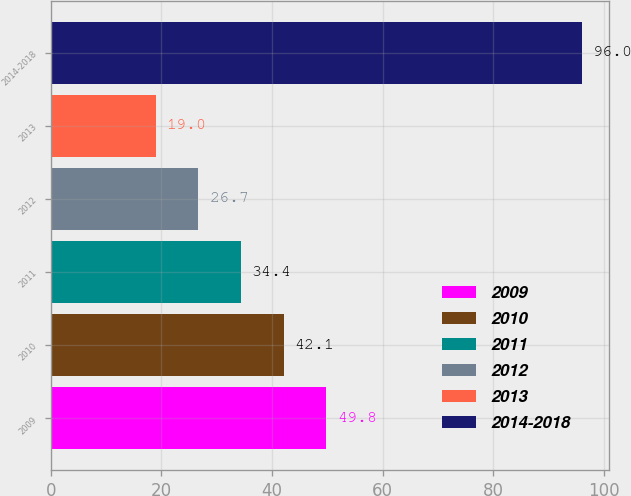<chart> <loc_0><loc_0><loc_500><loc_500><bar_chart><fcel>2009<fcel>2010<fcel>2011<fcel>2012<fcel>2013<fcel>2014-2018<nl><fcel>49.8<fcel>42.1<fcel>34.4<fcel>26.7<fcel>19<fcel>96<nl></chart> 